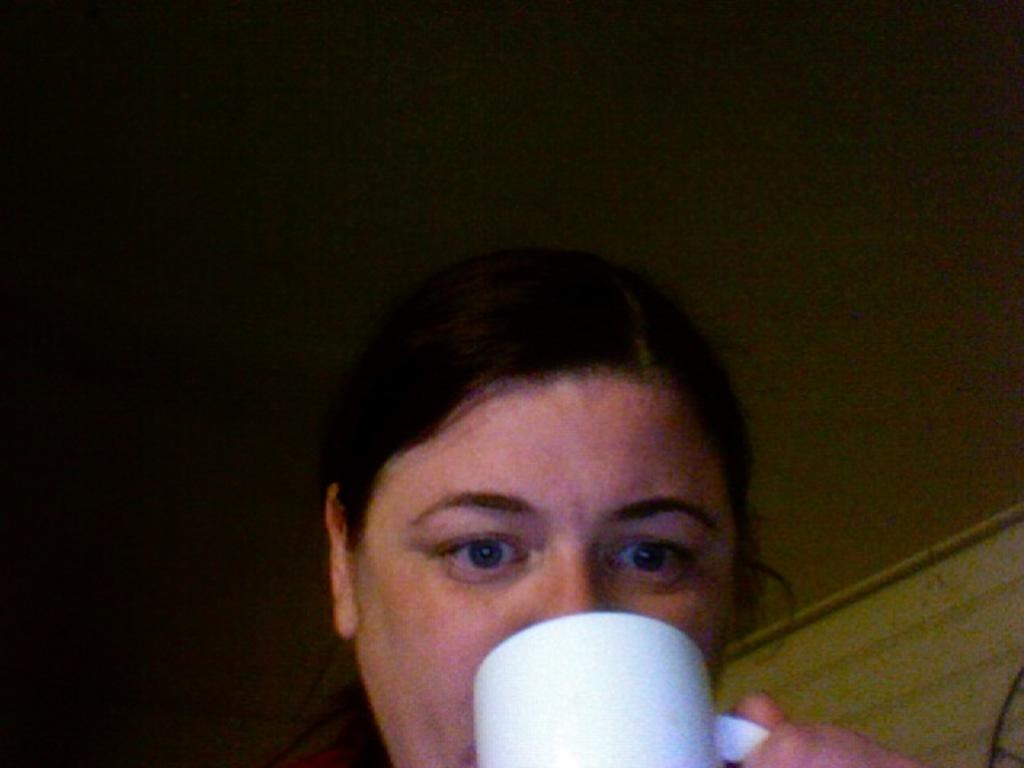Who or what is present in the image? There is a person in the image. What is the person holding in the image? The person is holding a cup with her hand. What type of building is depicted in the image? There is no building present in the image; it only features a person holding a cup. 